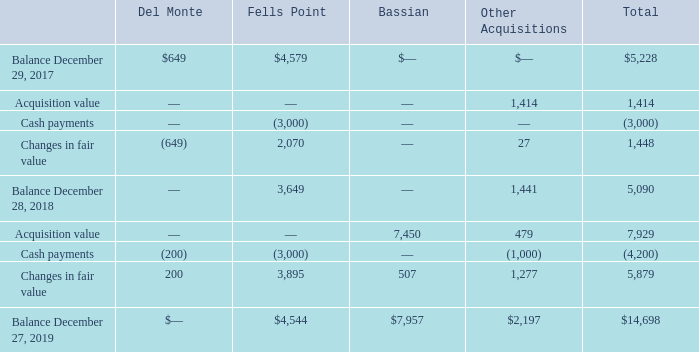Note 4 – Fair Value Measurements
Assets and Liabilities Measured at Fair Value
The Company’s contingent earn-out liabilities are measured at fair value. These liabilities were estimated using Level 3 inputs. The fair value of contingent consideration was determined based on a probability-based approach which includes projected results, percentage probability of occurrence and the application of a discount rate to present value the payments. A significant change in projected results, discount rate, or probabilities of occurrence could result in a significantly higher or lower fair value measurement. Changes in the fair value of contingent earn-out liabilities are reflected in operating expenses on the Company’s consolidated statements of operations.
The following table presents the changes in Level 3 contingent earn-out liabilities:
In May 2019, the Company fully settled its Del Monte earn-out liability for $200. The long-term portion of contingent earn-out liabilities was $7,957 and $2,792 as of December 27, 2019 and December 28, 2018, respectively, and are reflected as other liabilities and deferred credits on the Company’s consolidated balance sheets. The remaining short-term portion of earn-out liabilities are reflected as accrued liabilities on the Company’s consolidated balance sheets. Contingent earn-out liability payments in excess of the acquisition date fair value of the underlying contingent earn-out liability are classified as operating activities on the Company’s consolidated statements of cash flows and all other such payments are classified as financing activities.
What information does the table present? The changes in level 3 contingent earn-out liabilities. What is the total Balance in December 29, 2017? $5,228. What is the amount the Company used in May 2019 to settle its Del Monte earn-out liability? $200. What is the change in total balance between fiscal years 2017 and 2018? 5,228-5,090
Answer: 138. What is the average long-term portion of contingent earn-out liabilities for 2018 and 2019? (7,957+ 2,792)/2
Answer: 5374.5. What is the change in long-term portion of contingent earn-out liabilities for 2018 and 2019? 7,957-2,792
Answer: 5165. 